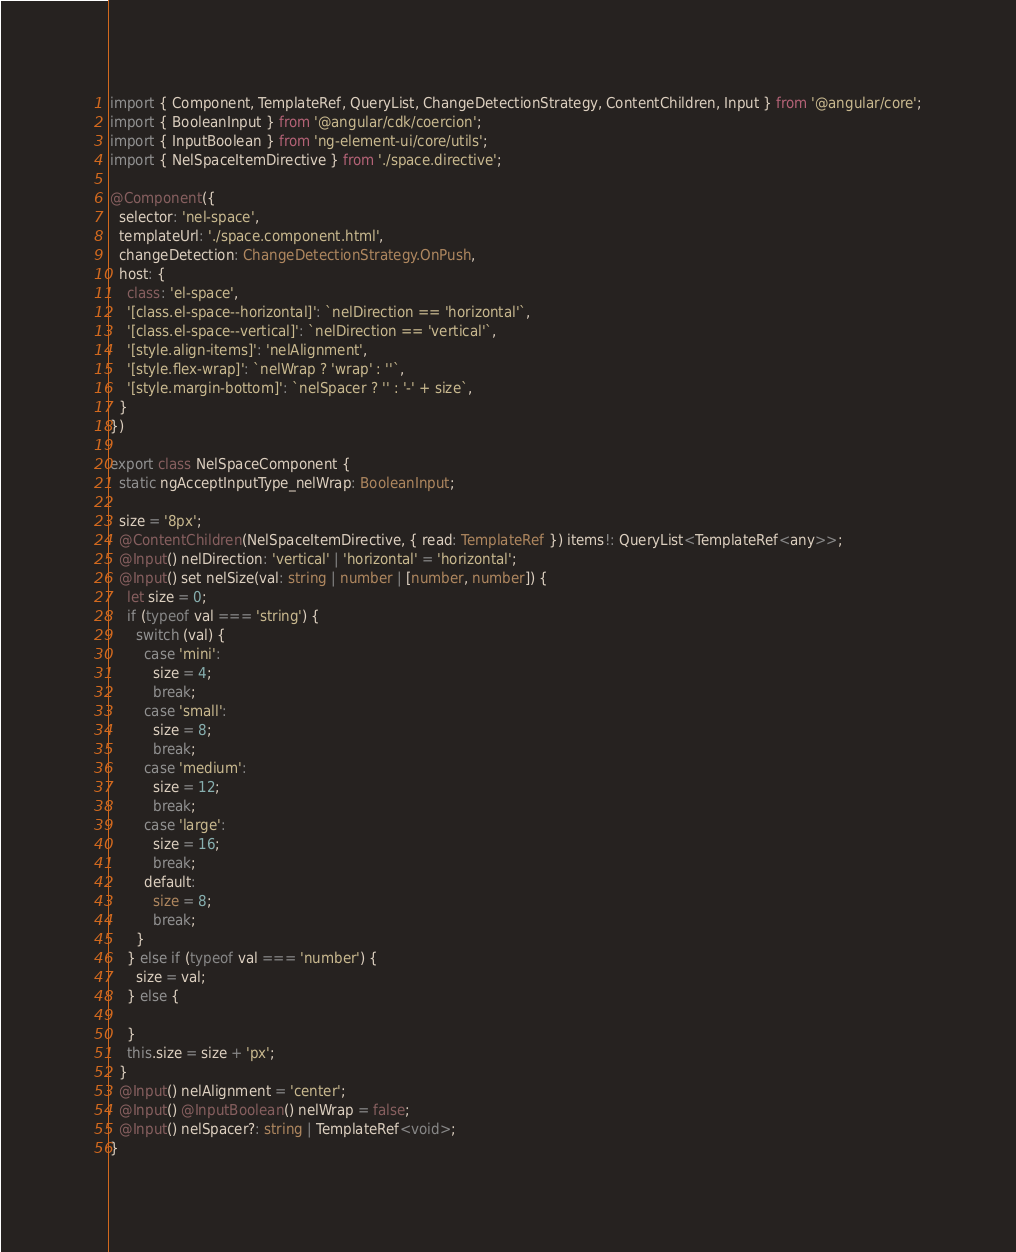<code> <loc_0><loc_0><loc_500><loc_500><_TypeScript_>import { Component, TemplateRef, QueryList, ChangeDetectionStrategy, ContentChildren, Input } from '@angular/core';
import { BooleanInput } from '@angular/cdk/coercion';
import { InputBoolean } from 'ng-element-ui/core/utils';
import { NelSpaceItemDirective } from './space.directive';

@Component({
  selector: 'nel-space',
  templateUrl: './space.component.html',
  changeDetection: ChangeDetectionStrategy.OnPush,
  host: {
    class: 'el-space',
    '[class.el-space--horizontal]': `nelDirection == 'horizontal'`,
    '[class.el-space--vertical]': `nelDirection == 'vertical'`,
    '[style.align-items]': 'nelAlignment',
    '[style.flex-wrap]': `nelWrap ? 'wrap' : ''`,
    '[style.margin-bottom]': `nelSpacer ? '' : '-' + size`,
  }
})

export class NelSpaceComponent {
  static ngAcceptInputType_nelWrap: BooleanInput;

  size = '8px';
  @ContentChildren(NelSpaceItemDirective, { read: TemplateRef }) items!: QueryList<TemplateRef<any>>;
  @Input() nelDirection: 'vertical' | 'horizontal' = 'horizontal';
  @Input() set nelSize(val: string | number | [number, number]) {
    let size = 0;
    if (typeof val === 'string') {
      switch (val) {
        case 'mini':
          size = 4;
          break;
        case 'small':
          size = 8;
          break;
        case 'medium':
          size = 12;
          break;
        case 'large':
          size = 16;
          break;
        default:
          size = 8;
          break;
      }
    } else if (typeof val === 'number') {
      size = val;
    } else {

    }
    this.size = size + 'px';
  }
  @Input() nelAlignment = 'center';
  @Input() @InputBoolean() nelWrap = false;
  @Input() nelSpacer?: string | TemplateRef<void>;
}
</code> 